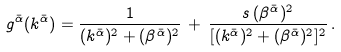<formula> <loc_0><loc_0><loc_500><loc_500>g ^ { \bar { \alpha } } ( k ^ { \bar { \alpha } } ) = \frac { 1 } { ( k ^ { \bar { \alpha } } ) ^ { 2 } + ( \beta ^ { \bar { \alpha } } ) ^ { 2 } } \, + \, \frac { s \, ( \beta ^ { \bar { \alpha } } ) ^ { 2 } } { [ ( k ^ { \bar { \alpha } } ) ^ { 2 } + ( \beta ^ { \bar { \alpha } } ) ^ { 2 } ] ^ { 2 } } \, .</formula> 